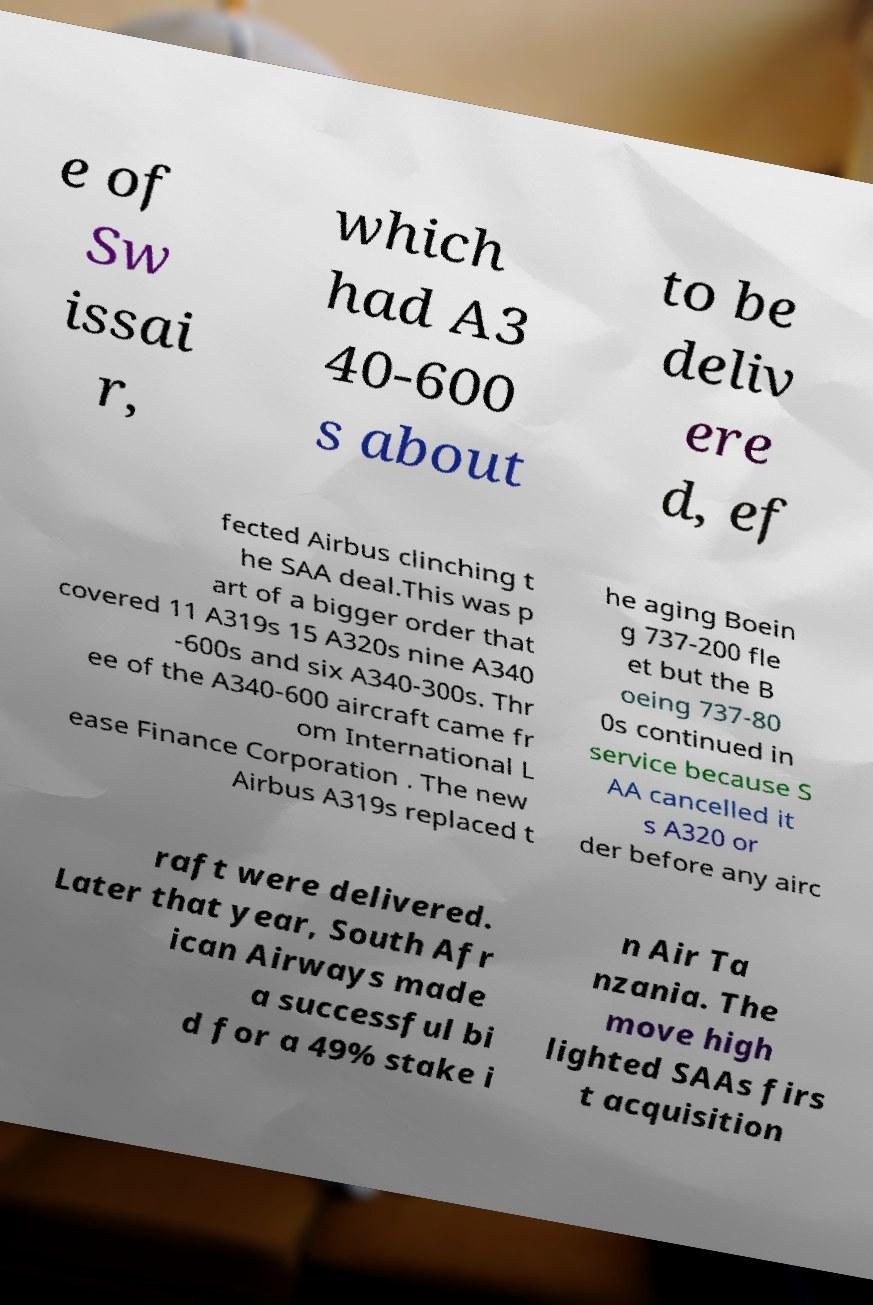There's text embedded in this image that I need extracted. Can you transcribe it verbatim? e of Sw issai r, which had A3 40-600 s about to be deliv ere d, ef fected Airbus clinching t he SAA deal.This was p art of a bigger order that covered 11 A319s 15 A320s nine A340 -600s and six A340-300s. Thr ee of the A340-600 aircraft came fr om International L ease Finance Corporation . The new Airbus A319s replaced t he aging Boein g 737-200 fle et but the B oeing 737-80 0s continued in service because S AA cancelled it s A320 or der before any airc raft were delivered. Later that year, South Afr ican Airways made a successful bi d for a 49% stake i n Air Ta nzania. The move high lighted SAAs firs t acquisition 